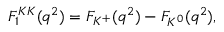<formula> <loc_0><loc_0><loc_500><loc_500>F _ { 1 } ^ { K K } ( q ^ { 2 } ) = F _ { K ^ { + } } ( q ^ { 2 } ) - F _ { K ^ { 0 } } ( q ^ { 2 } ) ,</formula> 